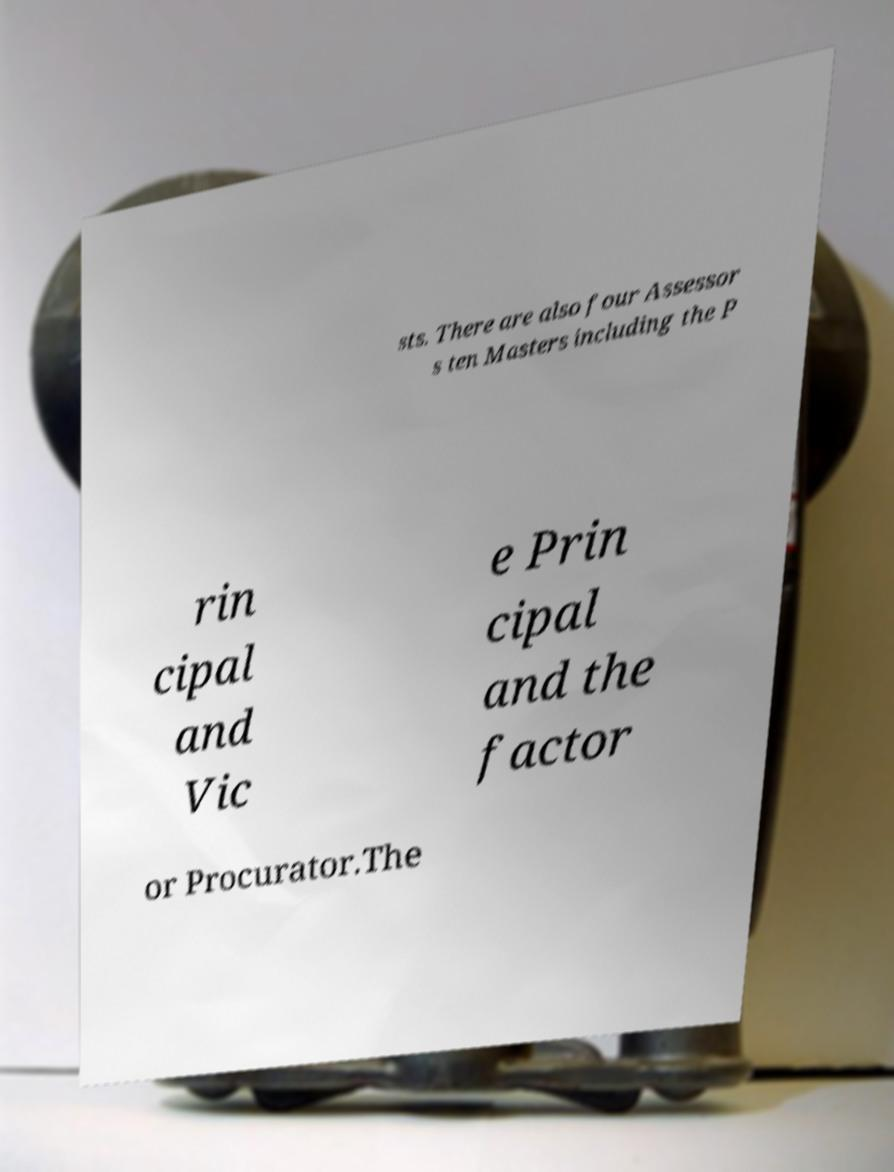Could you assist in decoding the text presented in this image and type it out clearly? sts. There are also four Assessor s ten Masters including the P rin cipal and Vic e Prin cipal and the factor or Procurator.The 